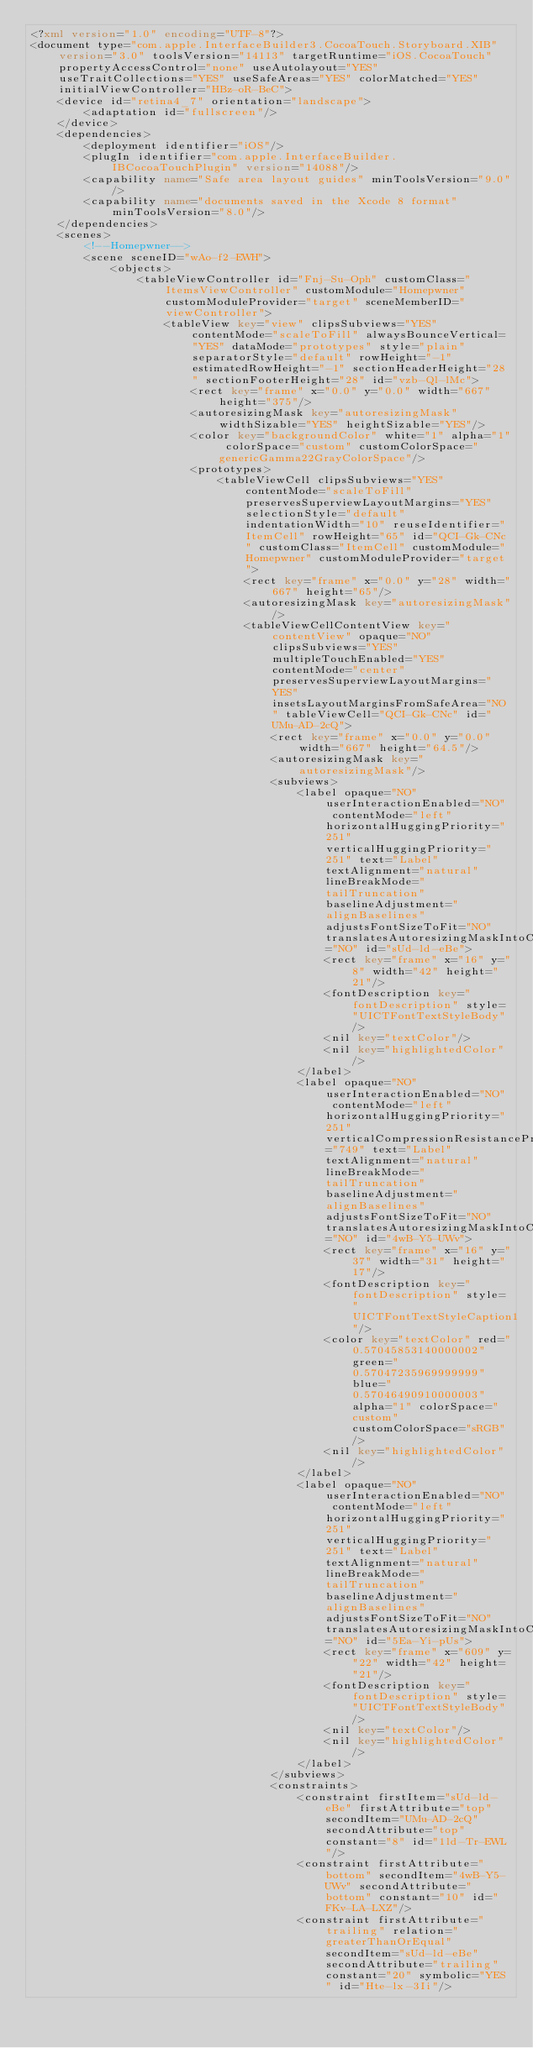Convert code to text. <code><loc_0><loc_0><loc_500><loc_500><_XML_><?xml version="1.0" encoding="UTF-8"?>
<document type="com.apple.InterfaceBuilder3.CocoaTouch.Storyboard.XIB" version="3.0" toolsVersion="14113" targetRuntime="iOS.CocoaTouch" propertyAccessControl="none" useAutolayout="YES" useTraitCollections="YES" useSafeAreas="YES" colorMatched="YES" initialViewController="HBz-oR-BeC">
    <device id="retina4_7" orientation="landscape">
        <adaptation id="fullscreen"/>
    </device>
    <dependencies>
        <deployment identifier="iOS"/>
        <plugIn identifier="com.apple.InterfaceBuilder.IBCocoaTouchPlugin" version="14088"/>
        <capability name="Safe area layout guides" minToolsVersion="9.0"/>
        <capability name="documents saved in the Xcode 8 format" minToolsVersion="8.0"/>
    </dependencies>
    <scenes>
        <!--Homepwner-->
        <scene sceneID="wAo-f2-EWH">
            <objects>
                <tableViewController id="Fnj-Su-Oph" customClass="ItemsViewController" customModule="Homepwner" customModuleProvider="target" sceneMemberID="viewController">
                    <tableView key="view" clipsSubviews="YES" contentMode="scaleToFill" alwaysBounceVertical="YES" dataMode="prototypes" style="plain" separatorStyle="default" rowHeight="-1" estimatedRowHeight="-1" sectionHeaderHeight="28" sectionFooterHeight="28" id="vzb-Ql-lMc">
                        <rect key="frame" x="0.0" y="0.0" width="667" height="375"/>
                        <autoresizingMask key="autoresizingMask" widthSizable="YES" heightSizable="YES"/>
                        <color key="backgroundColor" white="1" alpha="1" colorSpace="custom" customColorSpace="genericGamma22GrayColorSpace"/>
                        <prototypes>
                            <tableViewCell clipsSubviews="YES" contentMode="scaleToFill" preservesSuperviewLayoutMargins="YES" selectionStyle="default" indentationWidth="10" reuseIdentifier="ItemCell" rowHeight="65" id="QCI-Gk-CNc" customClass="ItemCell" customModule="Homepwner" customModuleProvider="target">
                                <rect key="frame" x="0.0" y="28" width="667" height="65"/>
                                <autoresizingMask key="autoresizingMask"/>
                                <tableViewCellContentView key="contentView" opaque="NO" clipsSubviews="YES" multipleTouchEnabled="YES" contentMode="center" preservesSuperviewLayoutMargins="YES" insetsLayoutMarginsFromSafeArea="NO" tableViewCell="QCI-Gk-CNc" id="UMu-AD-2cQ">
                                    <rect key="frame" x="0.0" y="0.0" width="667" height="64.5"/>
                                    <autoresizingMask key="autoresizingMask"/>
                                    <subviews>
                                        <label opaque="NO" userInteractionEnabled="NO" contentMode="left" horizontalHuggingPriority="251" verticalHuggingPriority="251" text="Label" textAlignment="natural" lineBreakMode="tailTruncation" baselineAdjustment="alignBaselines" adjustsFontSizeToFit="NO" translatesAutoresizingMaskIntoConstraints="NO" id="sUd-ld-eBe">
                                            <rect key="frame" x="16" y="8" width="42" height="21"/>
                                            <fontDescription key="fontDescription" style="UICTFontTextStyleBody"/>
                                            <nil key="textColor"/>
                                            <nil key="highlightedColor"/>
                                        </label>
                                        <label opaque="NO" userInteractionEnabled="NO" contentMode="left" horizontalHuggingPriority="251" verticalCompressionResistancePriority="749" text="Label" textAlignment="natural" lineBreakMode="tailTruncation" baselineAdjustment="alignBaselines" adjustsFontSizeToFit="NO" translatesAutoresizingMaskIntoConstraints="NO" id="4wB-Y5-UWv">
                                            <rect key="frame" x="16" y="37" width="31" height="17"/>
                                            <fontDescription key="fontDescription" style="UICTFontTextStyleCaption1"/>
                                            <color key="textColor" red="0.57045853140000002" green="0.57047235969999999" blue="0.57046490910000003" alpha="1" colorSpace="custom" customColorSpace="sRGB"/>
                                            <nil key="highlightedColor"/>
                                        </label>
                                        <label opaque="NO" userInteractionEnabled="NO" contentMode="left" horizontalHuggingPriority="251" verticalHuggingPriority="251" text="Label" textAlignment="natural" lineBreakMode="tailTruncation" baselineAdjustment="alignBaselines" adjustsFontSizeToFit="NO" translatesAutoresizingMaskIntoConstraints="NO" id="5Ea-Yi-pUs">
                                            <rect key="frame" x="609" y="22" width="42" height="21"/>
                                            <fontDescription key="fontDescription" style="UICTFontTextStyleBody"/>
                                            <nil key="textColor"/>
                                            <nil key="highlightedColor"/>
                                        </label>
                                    </subviews>
                                    <constraints>
                                        <constraint firstItem="sUd-ld-eBe" firstAttribute="top" secondItem="UMu-AD-2cQ" secondAttribute="top" constant="8" id="1ld-Tr-EWL"/>
                                        <constraint firstAttribute="bottom" secondItem="4wB-Y5-UWv" secondAttribute="bottom" constant="10" id="FKv-LA-LXZ"/>
                                        <constraint firstAttribute="trailing" relation="greaterThanOrEqual" secondItem="sUd-ld-eBe" secondAttribute="trailing" constant="20" symbolic="YES" id="Hte-lx-3Ii"/></code> 